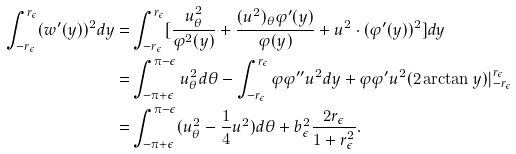<formula> <loc_0><loc_0><loc_500><loc_500>\int _ { - r _ { \epsilon } } ^ { r _ { \epsilon } } ( w ^ { \prime } ( y ) ) ^ { 2 } d y = & \int _ { - r _ { \epsilon } } ^ { r _ { \epsilon } } [ \frac { u _ { \theta } ^ { 2 } } { \varphi ^ { 2 } ( y ) } + \frac { ( u ^ { 2 } ) _ { \theta } \varphi ^ { \prime } ( y ) } { \varphi ( y ) } + u ^ { 2 } \cdot ( \varphi ^ { \prime } ( y ) ) ^ { 2 } ] d y \\ = & \int _ { - \pi + \epsilon } ^ { \pi - \epsilon } u ^ { 2 } _ { \theta } d \theta - \int _ { - r _ { \epsilon } } ^ { r _ { \epsilon } } \varphi \varphi ^ { \prime \prime } u ^ { 2 } d y + \varphi \varphi ^ { \prime } u ^ { 2 } ( 2 \arctan y ) | _ { - r _ { \epsilon } } ^ { r _ { \epsilon } } \\ = & \int _ { - \pi + \epsilon } ^ { \pi - \epsilon } ( u ^ { 2 } _ { \theta } - \frac { 1 } { 4 } u ^ { 2 } ) d \theta + b _ { \epsilon } ^ { 2 } \frac { 2 r _ { \epsilon } } { 1 + r _ { \epsilon } ^ { 2 } } .</formula> 